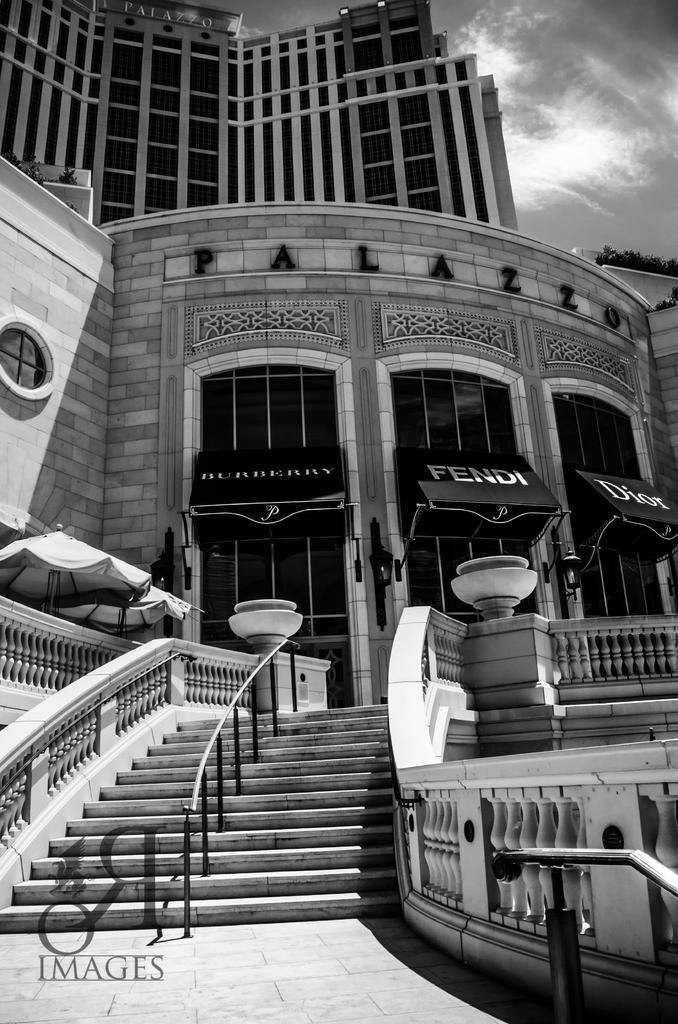What type of structure is present in the image? There is a building in the image. What else can be seen in the image besides the building? There are objects in the image. What can be seen in the background of the image? The sky is visible in the background of the image. Where is the text located in the image? The text is in the bottom left of the image. What is the interest rate on the sugar in the image? There is no sugar or interest rate mentioned in the image. 